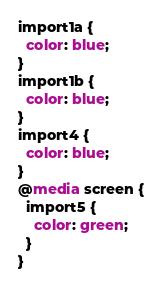Convert code to text. <code><loc_0><loc_0><loc_500><loc_500><_CSS_>import1a {
  color: blue;
}
import1b {
  color: blue;
}
import4 {
  color: blue;
}
@media screen {
  import5 {
    color: green;
  }
}
</code> 